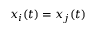<formula> <loc_0><loc_0><loc_500><loc_500>x _ { i } ( t ) = x _ { j } ( t )</formula> 